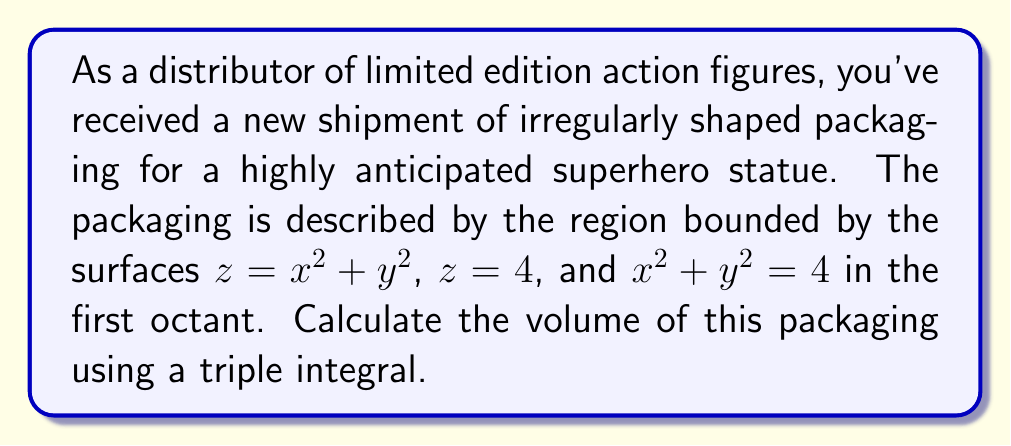Provide a solution to this math problem. To calculate the volume of the irregularly shaped packaging, we need to set up and evaluate a triple integral. Let's approach this step-by-step:

1) First, we identify the bounds of our region:
   - The base of the region is a quarter circle in the first quadrant of the xy-plane, bounded by $x^2 + y^2 = 4$.
   - The lower surface is $z = x^2 + y^2$.
   - The upper surface is the plane $z = 4$.

2) We'll use cylindrical coordinates for this problem, as the base is circular. The transformation is:
   $x = r\cos\theta$, $y = r\sin\theta$, $z = z$

3) In cylindrical coordinates, our bounds become:
   - $0 \leq r \leq 2$ (radius from 0 to 2)
   - $0 \leq \theta \leq \frac{\pi}{2}$ (angle from 0 to 90 degrees)
   - $r^2 \leq z \leq 4$ (height from lower to upper surface)

4) The volume integral in cylindrical coordinates is:

   $$V = \int_0^{\frac{\pi}{2}} \int_0^2 \int_{r^2}^4 r \, dz \, dr \, d\theta$$

5) Let's evaluate the integral from inside out:

   $$V = \int_0^{\frac{\pi}{2}} \int_0^2 r(4-r^2) \, dr \, d\theta$$

6) Evaluate the inner integral:

   $$V = \int_0^{\frac{\pi}{2}} \left[2r^2 - \frac{r^4}{4}\right]_0^2 \, d\theta$$
   
   $$= \int_0^{\frac{\pi}{2}} \left(8 - 4\right) \, d\theta = \int_0^{\frac{\pi}{2}} 4 \, d\theta$$

7) Finally, evaluate the outer integral:

   $$V = 4 \left[\theta\right]_0^{\frac{\pi}{2}} = 4 \cdot \frac{\pi}{2} = 2\pi$$

Therefore, the volume of the packaging is $2\pi$ cubic units.
Answer: $2\pi$ cubic units 